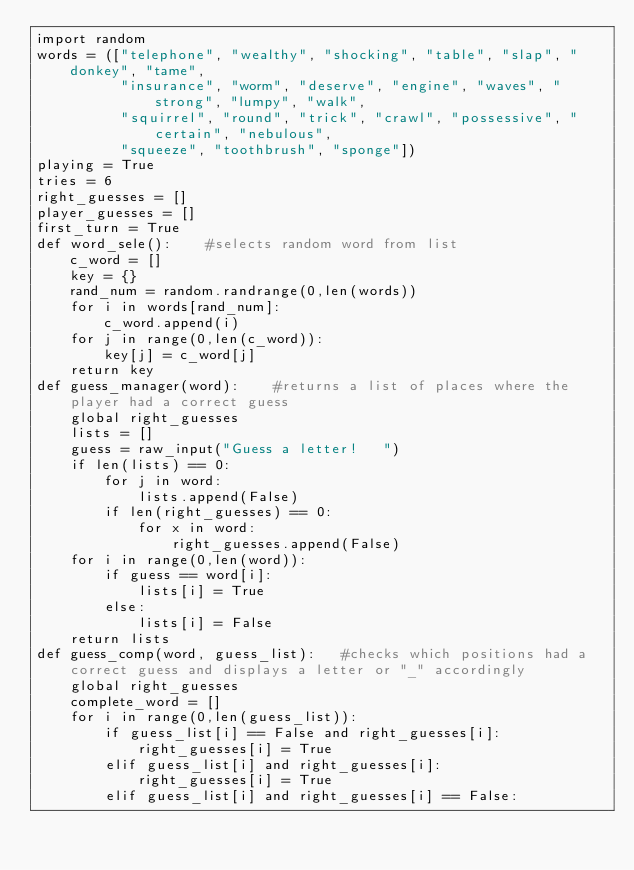Convert code to text. <code><loc_0><loc_0><loc_500><loc_500><_Python_>import random
words = (["telephone", "wealthy", "shocking", "table", "slap", "donkey", "tame",
          "insurance", "worm", "deserve", "engine", "waves", "strong", "lumpy", "walk",
          "squirrel", "round", "trick", "crawl", "possessive", "certain", "nebulous",
          "squeeze", "toothbrush", "sponge"])
playing = True
tries = 6
right_guesses = []
player_guesses = []
first_turn = True
def word_sele():    #selects random word from list
    c_word = []
    key = {}
    rand_num = random.randrange(0,len(words))
    for i in words[rand_num]:
        c_word.append(i)
    for j in range(0,len(c_word)):
        key[j] = c_word[j]
    return key
def guess_manager(word):    #returns a list of places where the player had a correct guess
    global right_guesses
    lists = []
    guess = raw_input("Guess a letter!   ")
    if len(lists) == 0:
        for j in word:
            lists.append(False)
        if len(right_guesses) == 0:
            for x in word:
                right_guesses.append(False)
    for i in range(0,len(word)):
        if guess == word[i]:
            lists[i] = True
        else:
            lists[i] = False
    return lists
def guess_comp(word, guess_list):   #checks which positions had a correct guess and displays a letter or "_" accordingly
    global right_guesses
    complete_word = []
    for i in range(0,len(guess_list)):
        if guess_list[i] == False and right_guesses[i]:
            right_guesses[i] = True
        elif guess_list[i] and right_guesses[i]:
            right_guesses[i] = True
        elif guess_list[i] and right_guesses[i] == False:</code> 